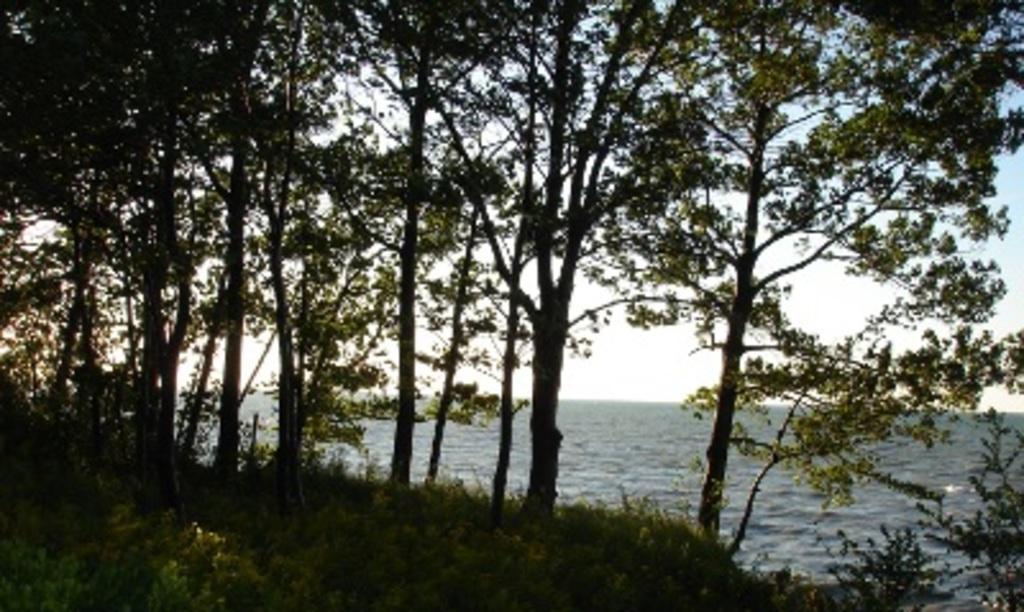Can you describe this image briefly? In this image I can see few plants which are green in color, few trees which are green and black in color, the water and the sky. 